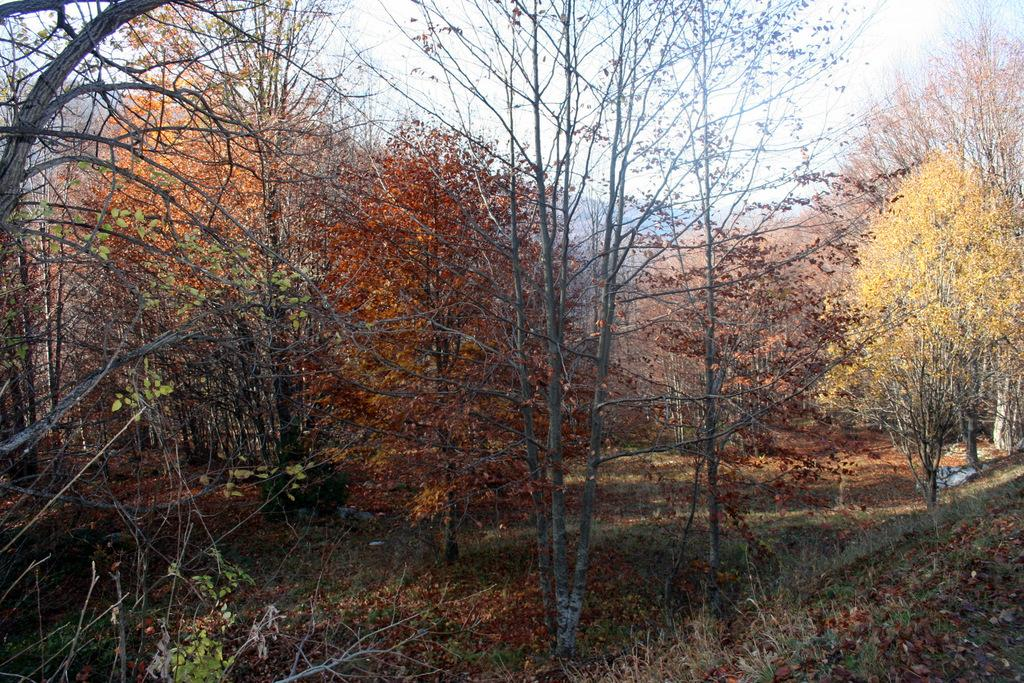What type of vegetation is visible in the image? There are many trees in the image. What type of ground cover can be seen in the image? There is grass visible in the image. What can be found on the ground among the trees and grass? Dry leaves are present on the ground in the image. What type of degree is being awarded to the tree in the image? There is no indication in the image that a tree is receiving any degree. Can you tell me how many blades are attached to the leaves of the trees in the image? Trees do not have blades; they have leaves, which are not individually counted in the image. 